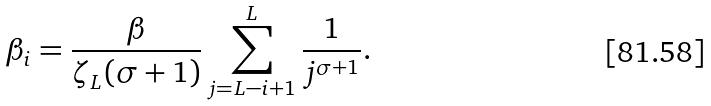Convert formula to latex. <formula><loc_0><loc_0><loc_500><loc_500>\beta _ { i } = \frac { \beta } { \zeta _ { L } ( \sigma + 1 ) } \sum _ { j = L - i + 1 } ^ { L } \frac { 1 } { j ^ { \sigma + 1 } } .</formula> 